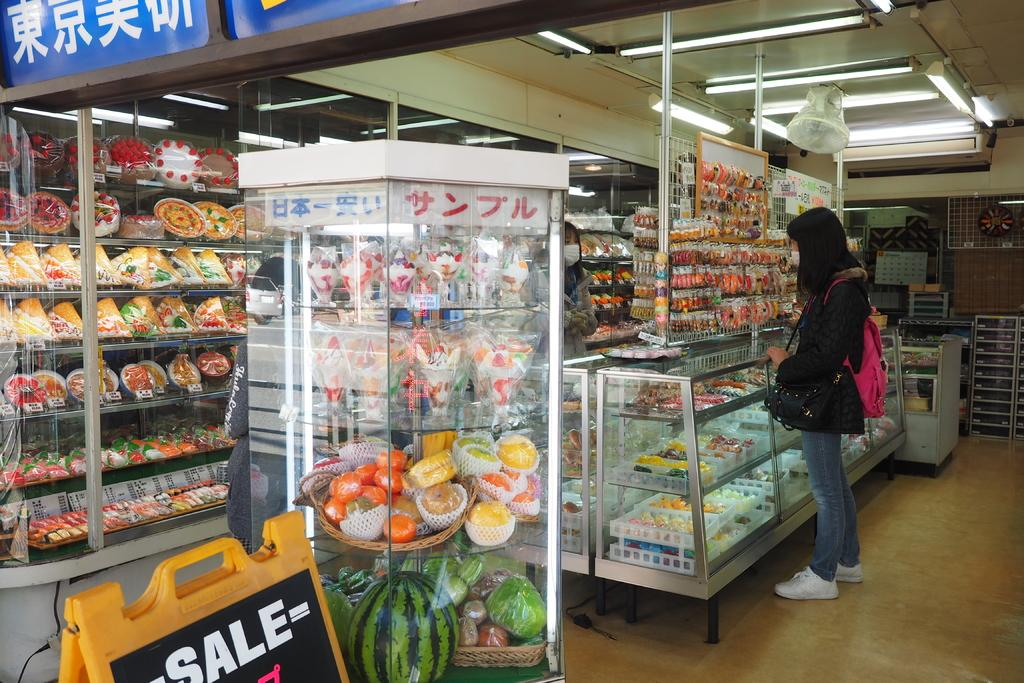<image>
Present a compact description of the photo's key features. a board on the ground that has the word sale on it 